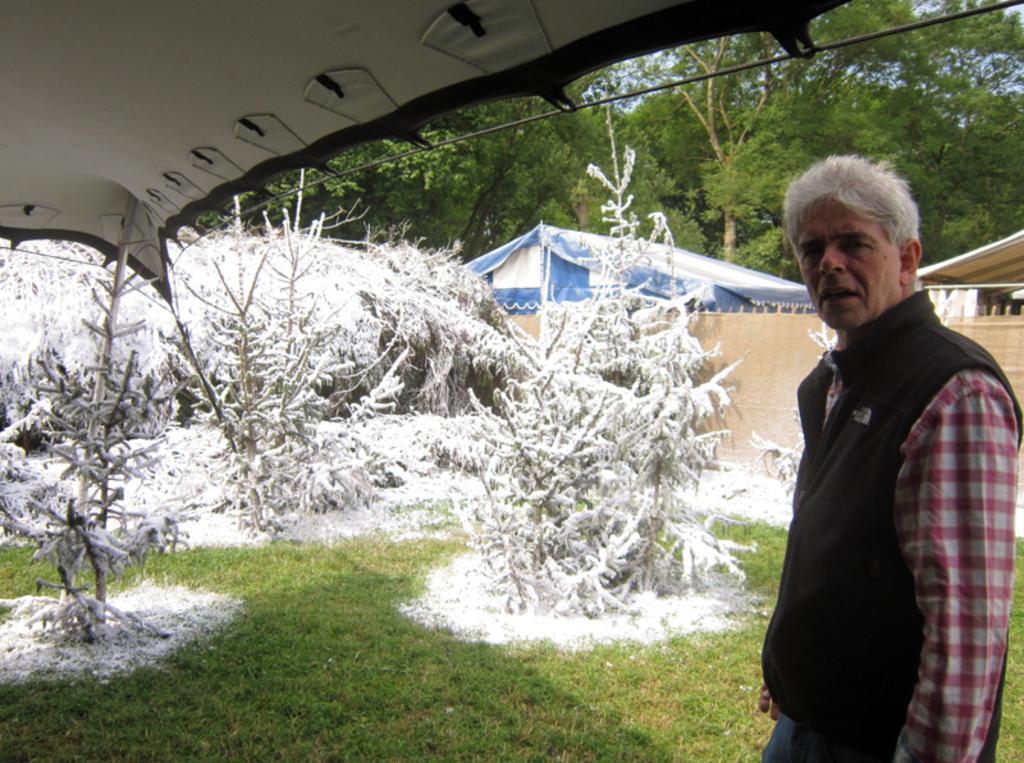Describe this image in one or two sentences. Here in this picture we can see a person standing on the ground, which is fully covered with grass over there, under a tent and behind him we can see trees, that are covered with snow over there and we can also see other tents and trees present all over there. 